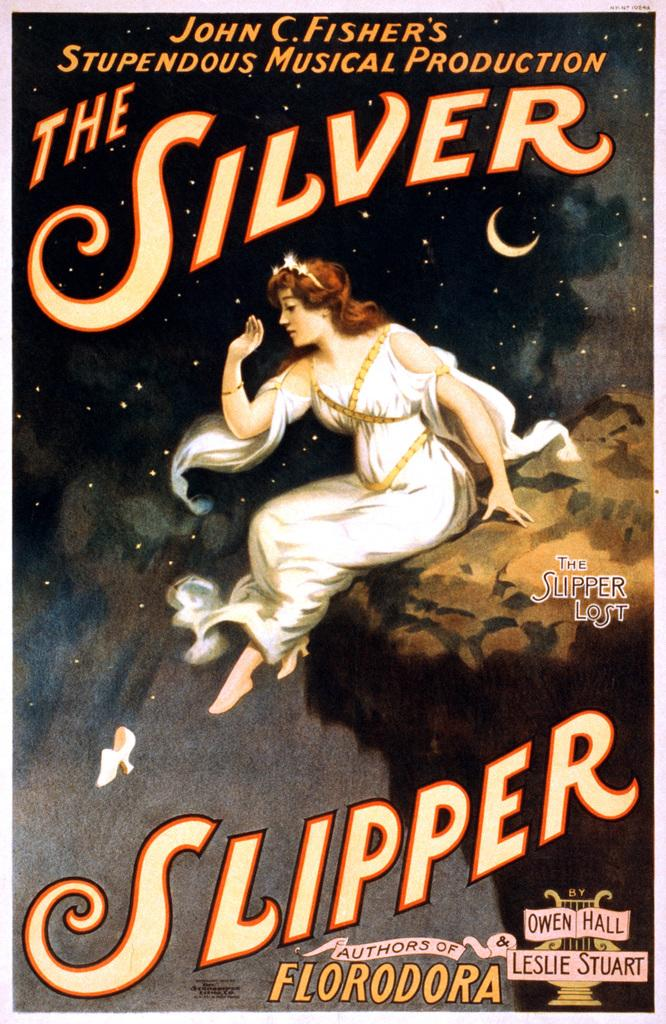<image>
Share a concise interpretation of the image provided. Cover for The Silver Slipper showing a woman sitting on a cliff. 